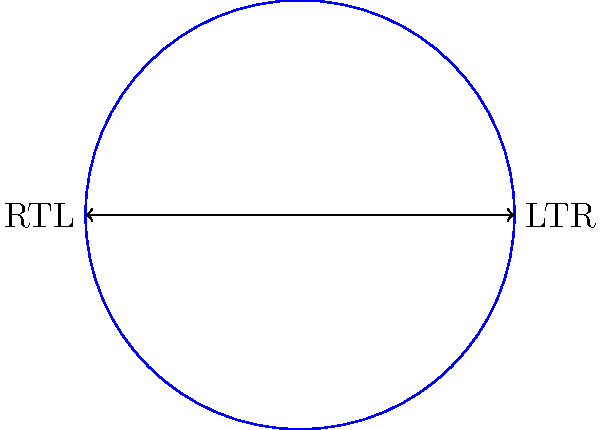In user interface localization for right-to-left (RTL) languages like Arabic, icons often need to be mirrored. What vector transformation can be applied to efficiently flip an icon horizontally without changing its vertical orientation? To flip an icon horizontally for RTL languages while maintaining its vertical orientation, we can use vector rotation. The process involves the following steps:

1. Represent the icon as a vector in 2D space, with its origin at the center of rotation.

2. Apply a 180-degree rotation around the vertical axis (y-axis) to this vector. This can be achieved using the 2D rotation matrix:

   $$R(\theta) = \begin{bmatrix} 
   \cos\theta & -\sin\theta \\
   \sin\theta & \cos\theta
   \end{bmatrix}$$

3. For a 180-degree rotation, $\theta = \pi$ radians. Substituting this into the rotation matrix:

   $$R(\pi) = \begin{bmatrix} 
   \cos\pi & -\sin\pi \\
   \sin\pi & \cos\pi
   \end{bmatrix} = \begin{bmatrix} 
   -1 & 0 \\
   0 & 1
   \end{bmatrix}$$

4. Applying this transformation to a vector $(x, y)$:

   $$\begin{bmatrix} 
   -1 & 0 \\
   0 & 1
   \end{bmatrix} \begin{bmatrix} 
   x \\
   y
   \end{bmatrix} = \begin{bmatrix} 
   -x \\
   y
   \end{bmatrix}$$

This transformation effectively flips the x-coordinate while leaving the y-coordinate unchanged, resulting in a horizontal mirror effect.

In practice, for bitmap icons, this can be implemented by iterating through the pixels and applying the transformation to each pixel's coordinates. For vector graphics, the transformation can be applied directly to the vector paths.
Answer: 180-degree rotation around the y-axis 